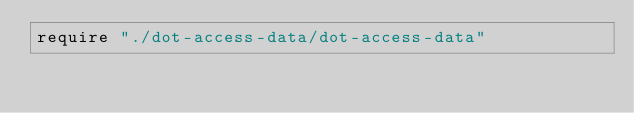<code> <loc_0><loc_0><loc_500><loc_500><_Crystal_>require "./dot-access-data/dot-access-data"
</code> 